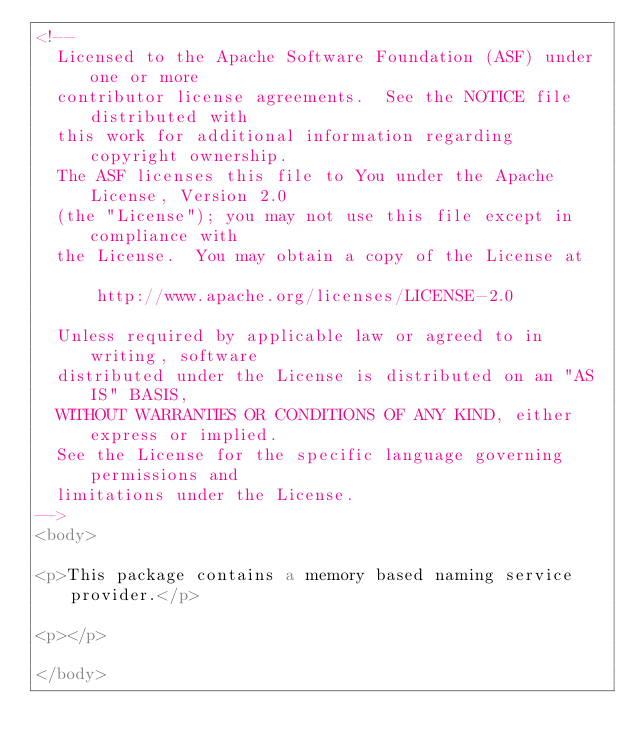<code> <loc_0><loc_0><loc_500><loc_500><_HTML_><!--
  Licensed to the Apache Software Foundation (ASF) under one or more
  contributor license agreements.  See the NOTICE file distributed with
  this work for additional information regarding copyright ownership.
  The ASF licenses this file to You under the Apache License, Version 2.0
  (the "License"); you may not use this file except in compliance with
  the License.  You may obtain a copy of the License at

      http://www.apache.org/licenses/LICENSE-2.0

  Unless required by applicable law or agreed to in writing, software
  distributed under the License is distributed on an "AS IS" BASIS,
  WITHOUT WARRANTIES OR CONDITIONS OF ANY KIND, either express or implied.
  See the License for the specific language governing permissions and
  limitations under the License.
-->
<body>

<p>This package contains a memory based naming service provider.</p>

<p></p>

</body>
</code> 